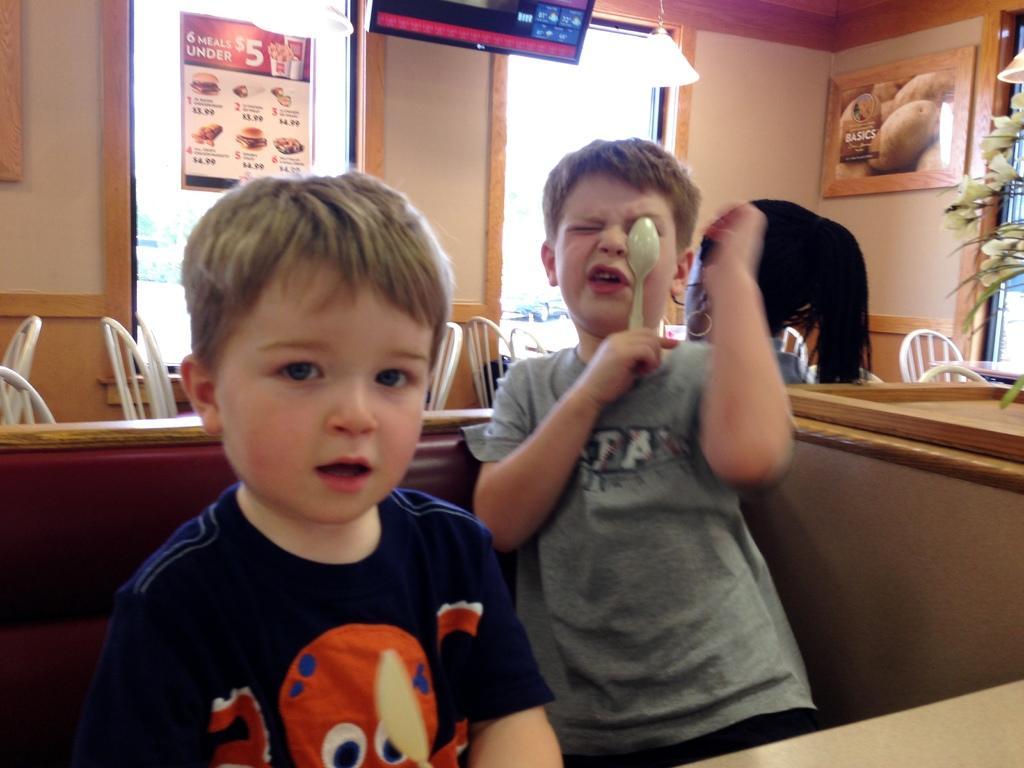Could you give a brief overview of what you see in this image? In this image, we can see kids and one of them is holding a spoon. In the background, there are chairs, a houseplant and there are boards on the wall and we can see a lady and there are stands. 